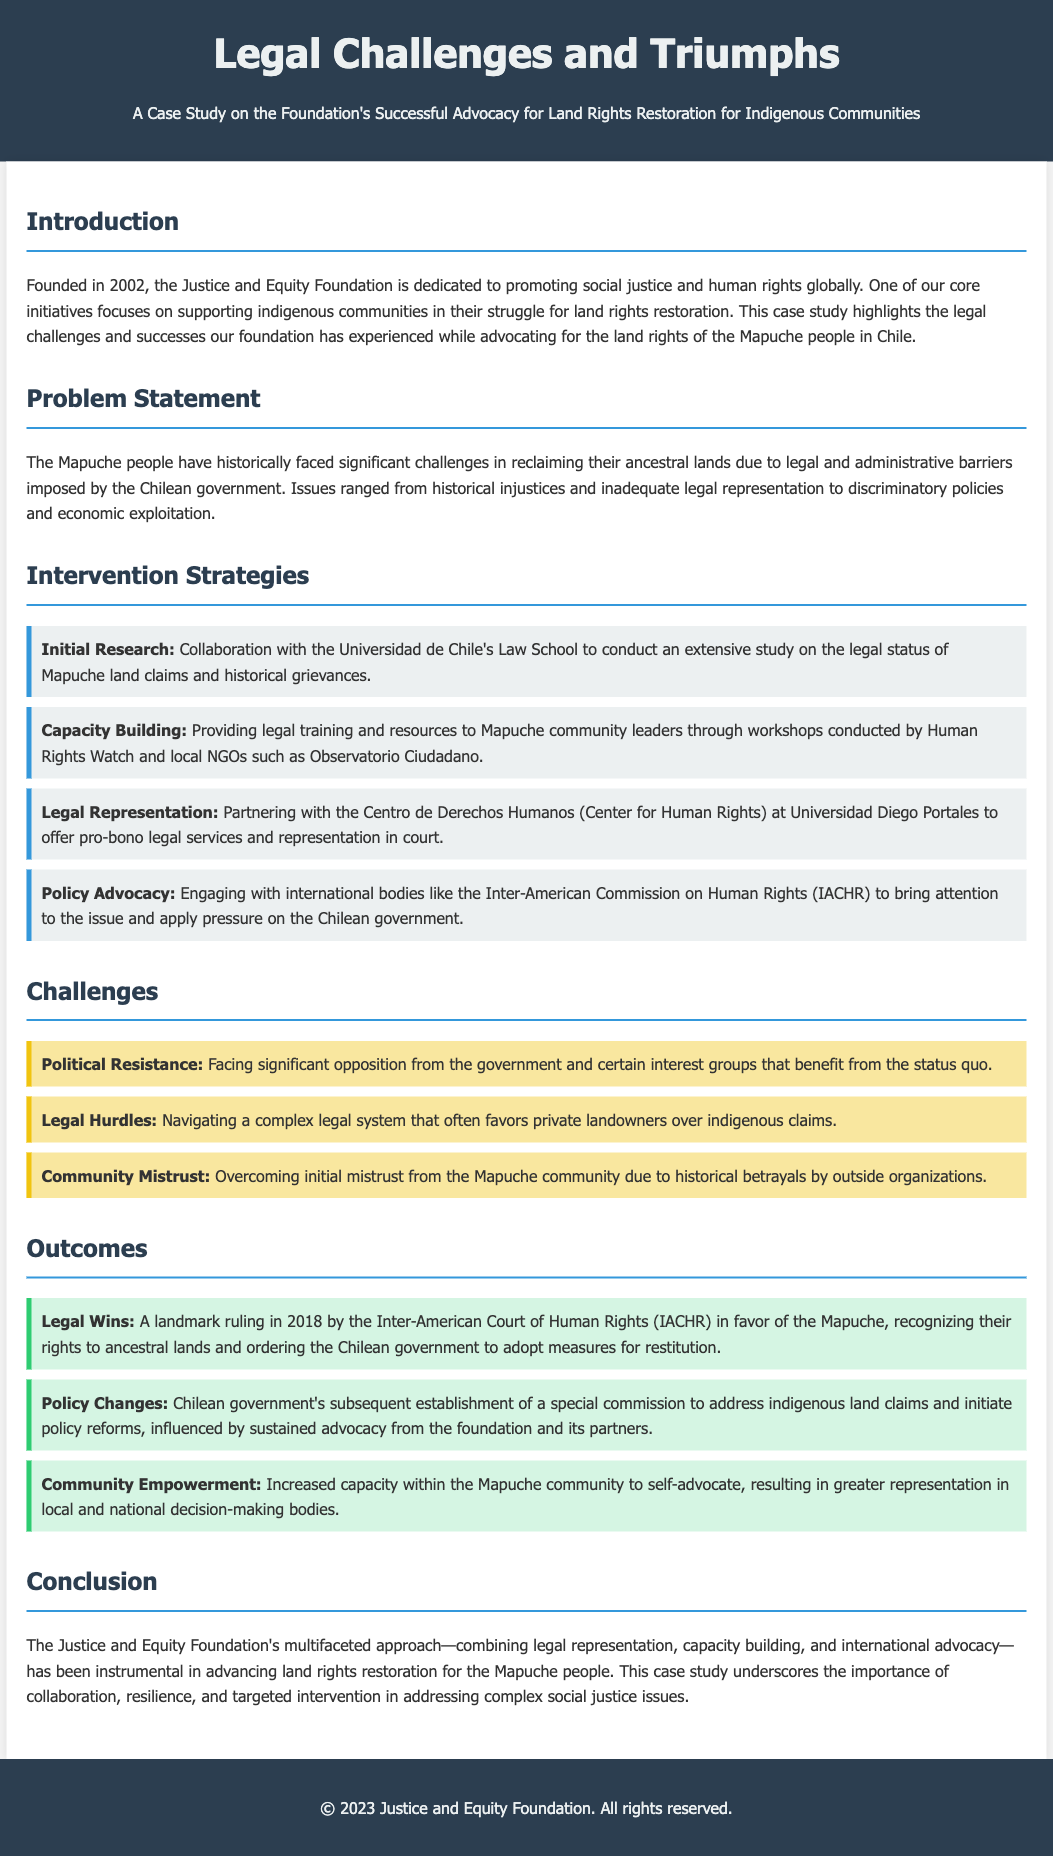What year was the Justice and Equity Foundation founded? The founding year of the Justice and Equity Foundation is stated in the introduction of the case study.
Answer: 2002 Who did the foundation collaborate with for initial research? The document mentions collaboration with the Universidad de Chile's Law School for the initial research.
Answer: Universidad de Chile's Law School What significant ruling occurred in 2018? The document provides details about a landmark ruling by the Inter-American Court of Human Rights regarding the Mapuche's rights.
Answer: landmark ruling What type of support was provided to community leaders? The case study specifies that legal training and resources were given to Mapuche community leaders.
Answer: legal training and resources Which commission was established by the Chilean government? The case study states that the Chilean government established a special commission to address indigenous land claims.
Answer: special commission What major barrier faced by the Mapuche community is mentioned in the challenges section? The challenges section outlines community mistrust as a significant barrier faced by the Mapuche community.
Answer: community mistrust Which organization provided pro-bono legal services? The document identifies the Centro de Derechos Humanos as the organization that partnered to provide pro-bono legal services.
Answer: Centro de Derechos Humanos What outcome resulted from increased capacity within the Mapuche community? According to the outcomes section, the increased capacity resulted in greater representation in decision-making bodies.
Answer: greater representation What was one of the foundation's strategies for policy advocacy? The document notes engagement with the Inter-American Commission on Human Rights as a strategy for policy advocacy.
Answer: engagement with the Inter-American Commission on Human Rights 